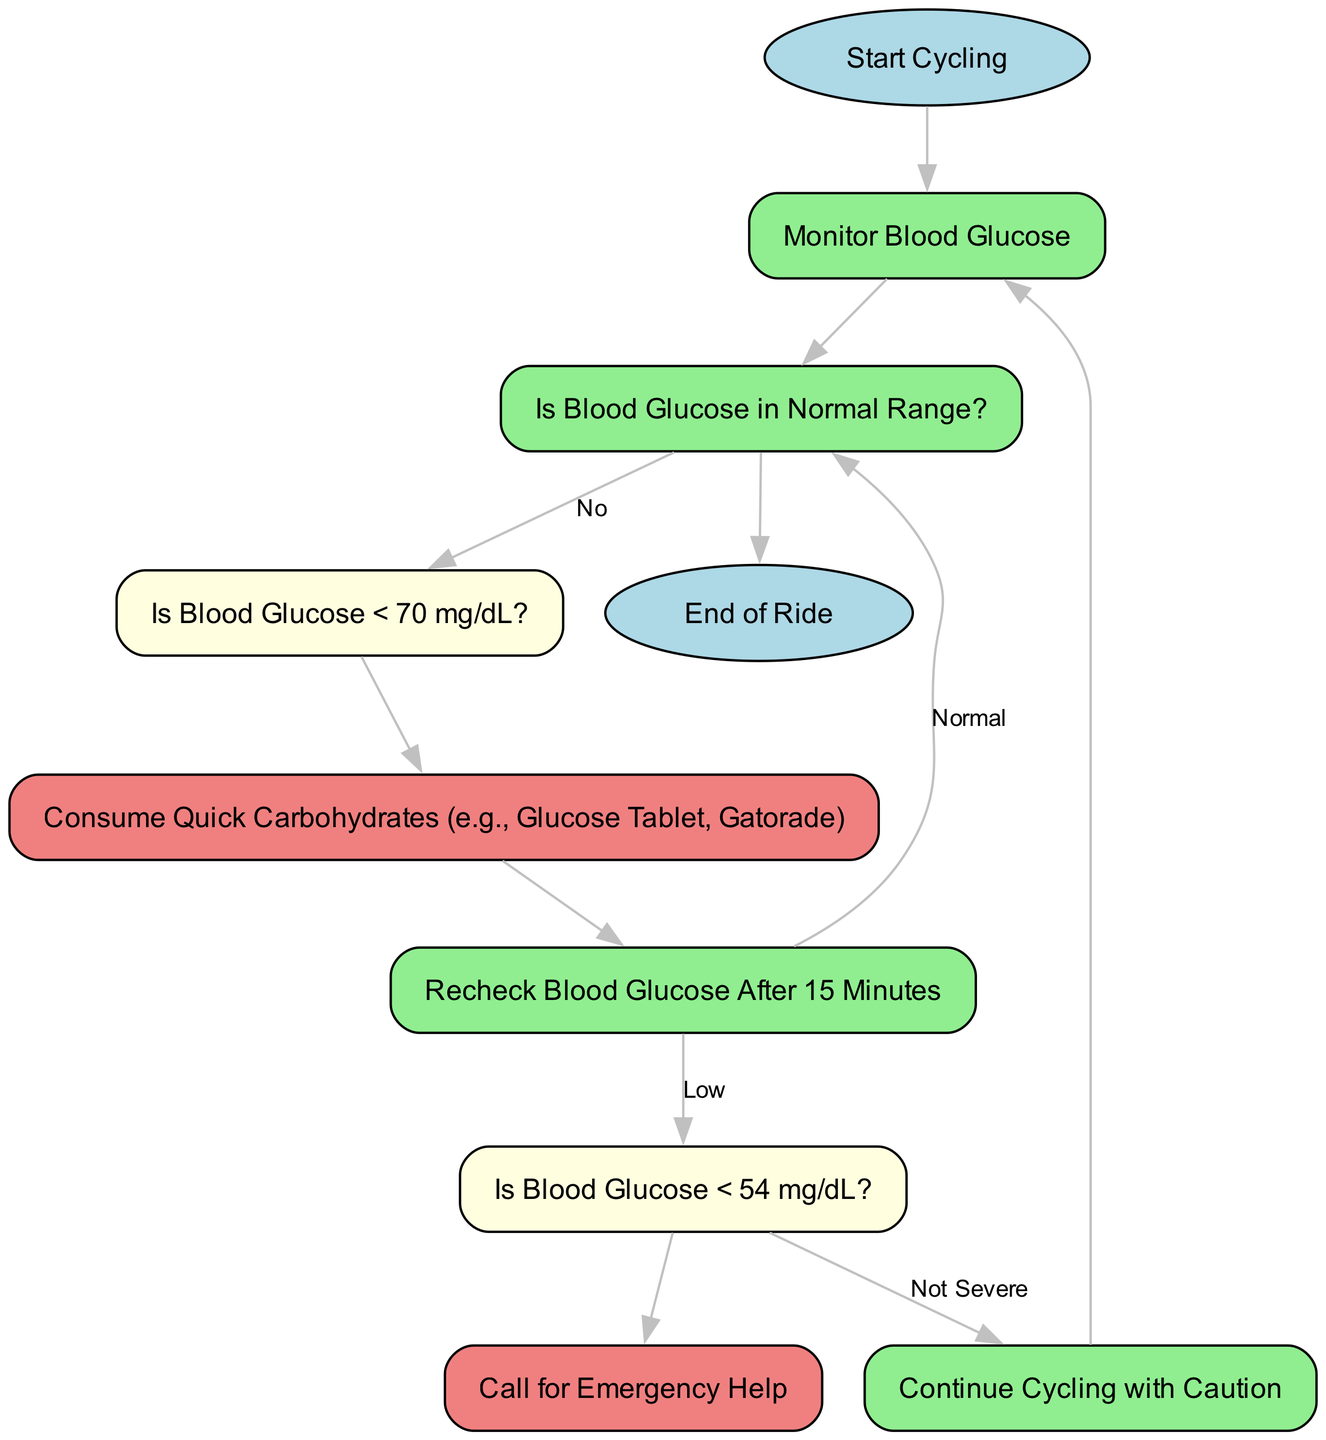What is the first step after starting to cycle? The first step indicated in the diagram after starting to cycle is to "Monitor Blood Glucose." This is the only node that follows "Start Cycling."
Answer: Monitor Blood Glucose How many nodes are there in total? By counting all the nodes in the diagram, including start and end points and all decision points, there are 10 nodes in total.
Answer: 10 What should you do if your blood glucose is below 70 mg/dL? According to the diagram, if blood glucose is below 70 mg/dL, you should "Consume Quick Carbohydrates (e.g., Glucose Tablet, Gatorade)." This is the action that follows the mild hypoglycemia check.
Answer: Consume Quick Carbohydrates What happens if blood glucose checks indicate a reading below 54 mg/dL? If blood glucose checks show a reading below 54 mg/dL, the diagram instructs to "Call for Emergency Help." This is the action associated with severe hypoglycemia.
Answer: Call for Emergency Help After consuming carbohydrates, how long should you wait to recheck glucose? The diagram specifies that you should "Recheck Blood Glucose After 15 Minutes" after consuming quick carbohydrates.
Answer: 15 Minutes If blood glucose returns to normal after rechecking, what is the next step? If the recheck shows blood glucose is normal, the next step is to go back to the "Normal Range," which leads directly to the "End of Ride." Thus, the process concludes there.
Answer: End of Ride What color represents consuming quick carbohydrates in the diagram? The color representing the node "Consume Quick Carbohydrates" in the diagram is light coral, which specifically denotes actions that need to be taken when facing hypoglycemia.
Answer: Light Coral Is it safe to continue cycling if hypoglycemia is not severe? Yes, according to the diagram, if blood glucose is less than 54 mg/dL but not classified as severe, you can "Continue Cycling with Caution." However, this is contingent on the condition being not severe as indicated in the node.
Answer: Continue Cycling with Caution What indicates that blood glucose is in a normal range after monitoring? The decision point "Is Blood Glucose in Normal Range?" in the diagram indicates that if blood glucose is normal, the path leads to the end, confirming that cycling can safely continue from that condition.
Answer: Normal Range 